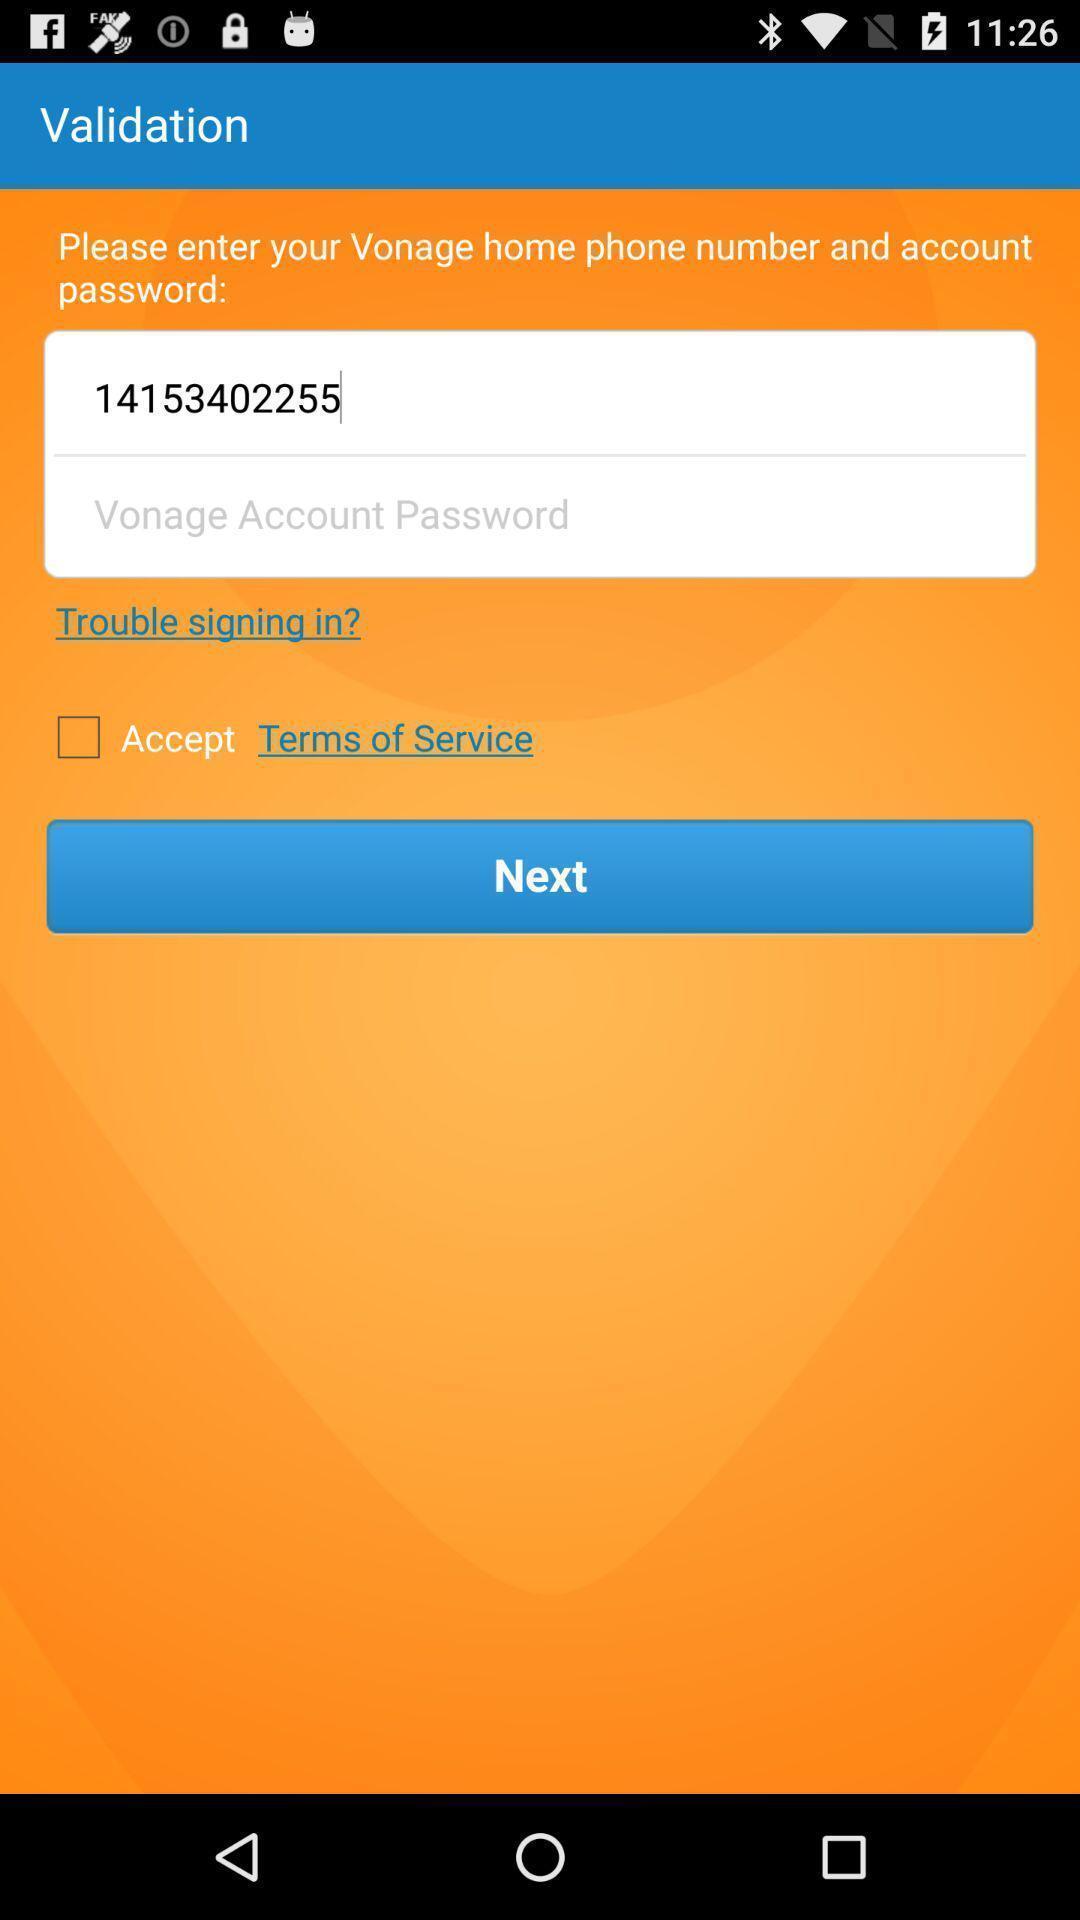What details can you identify in this image? Signin page in a calling app. 